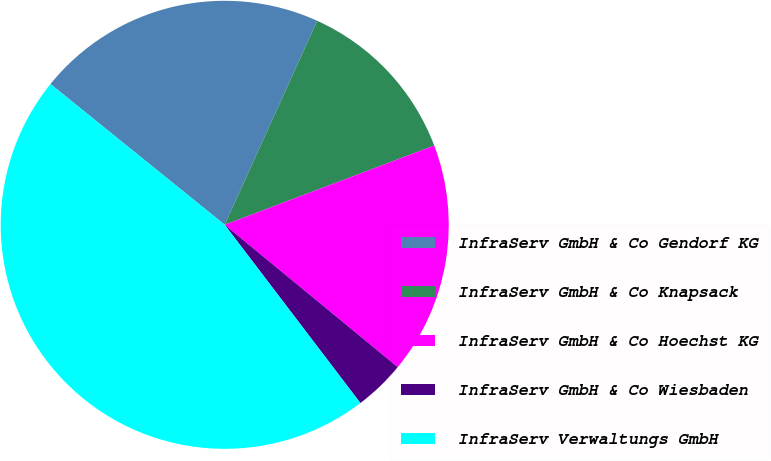Convert chart to OTSL. <chart><loc_0><loc_0><loc_500><loc_500><pie_chart><fcel>InfraServ GmbH & Co Gendorf KG<fcel>InfraServ GmbH & Co Knapsack<fcel>InfraServ GmbH & Co Hoechst KG<fcel>InfraServ GmbH & Co Wiesbaden<fcel>InfraServ Verwaltungs GmbH<nl><fcel>20.96%<fcel>12.47%<fcel>16.71%<fcel>3.69%<fcel>46.17%<nl></chart> 